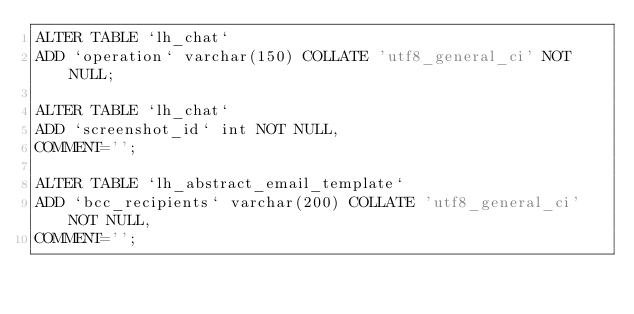<code> <loc_0><loc_0><loc_500><loc_500><_SQL_>ALTER TABLE `lh_chat`
ADD `operation` varchar(150) COLLATE 'utf8_general_ci' NOT NULL;

ALTER TABLE `lh_chat`
ADD `screenshot_id` int NOT NULL,
COMMENT='';

ALTER TABLE `lh_abstract_email_template`
ADD `bcc_recipients` varchar(200) COLLATE 'utf8_general_ci' NOT NULL,
COMMENT='';</code> 